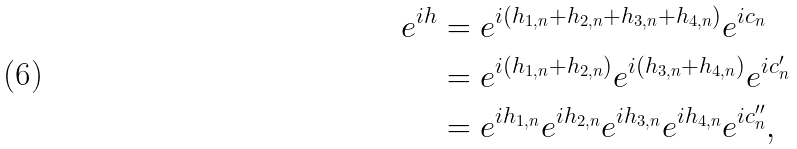Convert formula to latex. <formula><loc_0><loc_0><loc_500><loc_500>e ^ { i h } & = e ^ { i ( h _ { 1 , n } + h _ { 2 , n } + h _ { 3 , n } + h _ { 4 , n } ) } e ^ { i c _ { n } } \\ & = e ^ { i ( h _ { 1 , n } + h _ { 2 , n } ) } e ^ { i ( h _ { 3 , n } + h _ { 4 , n } ) } e ^ { i c _ { n } ^ { \prime } } \\ & = e ^ { i h _ { 1 , n } } e ^ { i h _ { 2 , n } } e ^ { i h _ { 3 , n } } e ^ { i h _ { 4 , n } } e ^ { i c _ { n } ^ { \prime \prime } } ,</formula> 